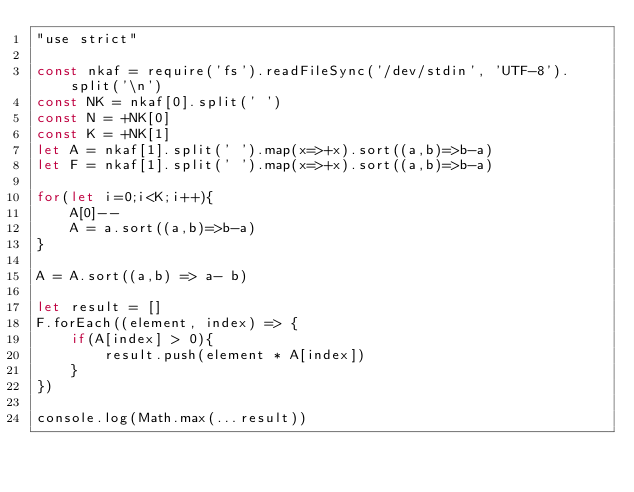Convert code to text. <code><loc_0><loc_0><loc_500><loc_500><_JavaScript_>"use strict"

const nkaf = require('fs').readFileSync('/dev/stdin', 'UTF-8').split('\n')
const NK = nkaf[0].split(' ')
const N = +NK[0]
const K = +NK[1]
let A = nkaf[1].split(' ').map(x=>+x).sort((a,b)=>b-a)
let F = nkaf[1].split(' ').map(x=>+x).sort((a,b)=>b-a)

for(let i=0;i<K;i++){
    A[0]--
    A = a.sort((a,b)=>b-a)
}

A = A.sort((a,b) => a- b)

let result = []
F.forEach((element, index) => {
    if(A[index] > 0){
        result.push(element * A[index])
    }
})

console.log(Math.max(...result))</code> 